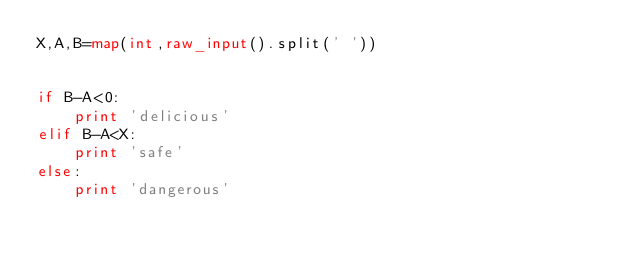Convert code to text. <code><loc_0><loc_0><loc_500><loc_500><_Python_>X,A,B=map(int,raw_input().split(' '))


if B-A<0:
    print 'delicious'
elif B-A<X:
    print 'safe'
else:
    print 'dangerous'</code> 